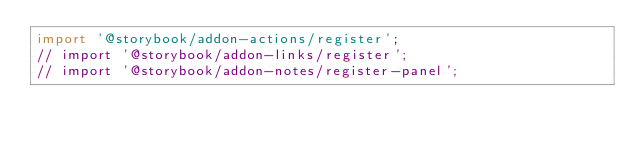<code> <loc_0><loc_0><loc_500><loc_500><_JavaScript_>import '@storybook/addon-actions/register';
// import '@storybook/addon-links/register';
// import '@storybook/addon-notes/register-panel';
</code> 